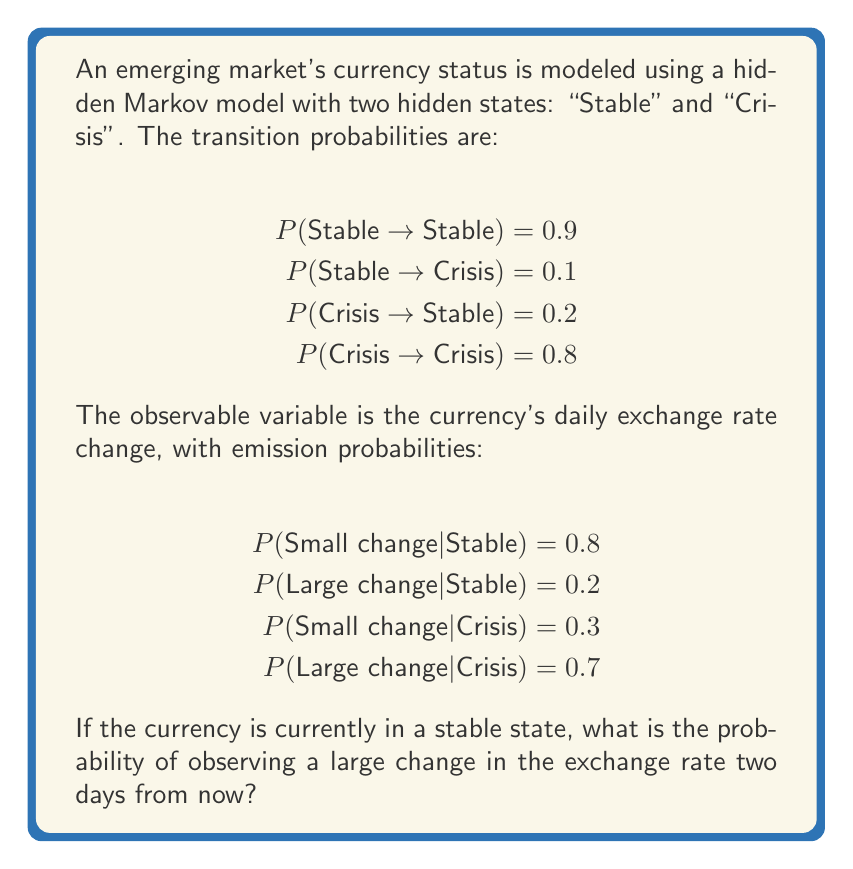Could you help me with this problem? To solve this problem, we need to follow these steps:

1) First, let's calculate the probability of being in each state after two days:

   Day 0: P(Stable) = 1, P(Crisis) = 0

   Day 1:
   P(Stable) = 1 * 0.9 + 0 * 0.2 = 0.9
   P(Crisis) = 1 * 0.1 + 0 * 0.8 = 0.1

   Day 2:
   P(Stable) = 0.9 * 0.9 + 0.1 * 0.2 = 0.83
   P(Crisis) = 0.9 * 0.1 + 0.1 * 0.8 = 0.17

2) Now, we need to calculate the probability of observing a large change given each state:

   P(Large change | Stable) = 0.2
   P(Large change | Crisis) = 0.7

3) We can use the law of total probability to calculate the final result:

   P(Large change on Day 2) = P(Large change | Stable) * P(Stable on Day 2) + 
                               P(Large change | Crisis) * P(Crisis on Day 2)

   = 0.2 * 0.83 + 0.7 * 0.17
   = 0.166 + 0.119
   = 0.285

Therefore, the probability of observing a large change in the exchange rate two days from now, given that the currency is currently in a stable state, is 0.285 or 28.5%.
Answer: 0.285 